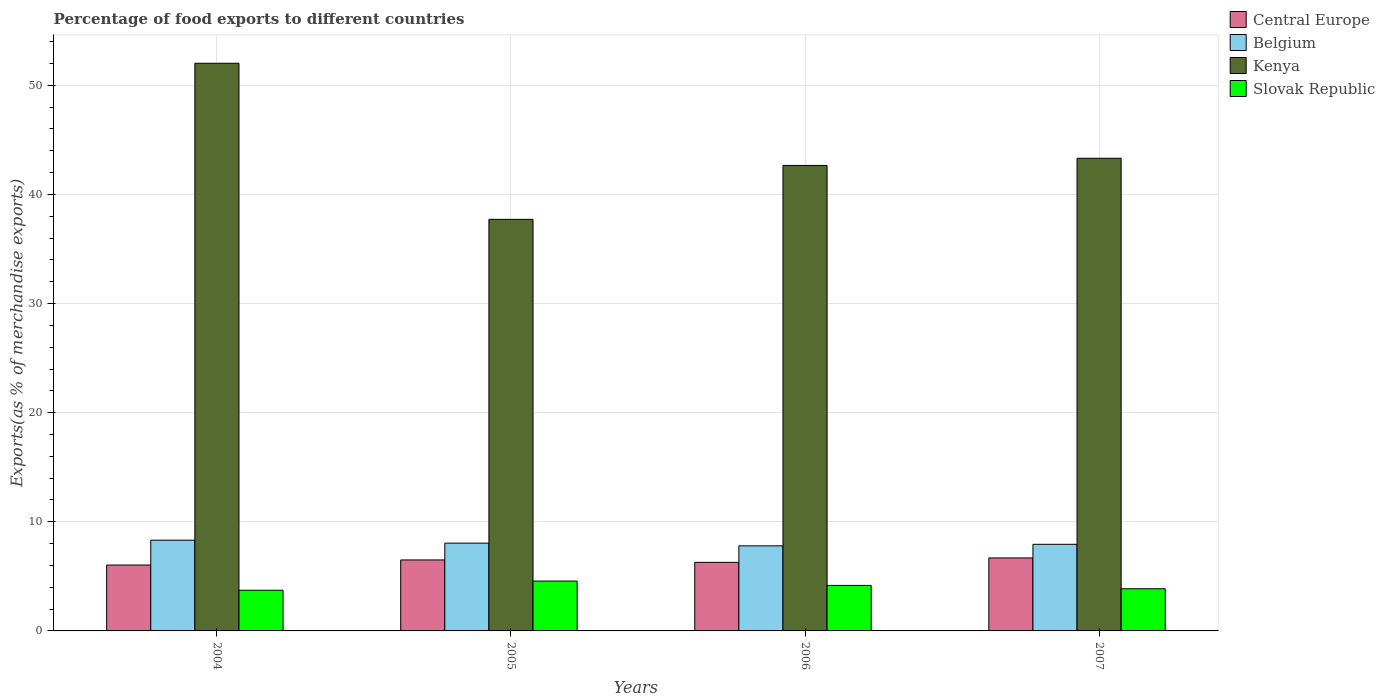Are the number of bars per tick equal to the number of legend labels?
Ensure brevity in your answer.  Yes. Are the number of bars on each tick of the X-axis equal?
Your answer should be compact. Yes. How many bars are there on the 1st tick from the left?
Make the answer very short. 4. How many bars are there on the 4th tick from the right?
Give a very brief answer. 4. In how many cases, is the number of bars for a given year not equal to the number of legend labels?
Your response must be concise. 0. What is the percentage of exports to different countries in Slovak Republic in 2005?
Provide a succinct answer. 4.57. Across all years, what is the maximum percentage of exports to different countries in Central Europe?
Offer a terse response. 6.69. Across all years, what is the minimum percentage of exports to different countries in Central Europe?
Your response must be concise. 6.04. In which year was the percentage of exports to different countries in Belgium maximum?
Ensure brevity in your answer.  2004. What is the total percentage of exports to different countries in Belgium in the graph?
Offer a very short reply. 32.09. What is the difference between the percentage of exports to different countries in Kenya in 2004 and that in 2007?
Provide a short and direct response. 8.7. What is the difference between the percentage of exports to different countries in Slovak Republic in 2005 and the percentage of exports to different countries in Kenya in 2006?
Offer a terse response. -38.09. What is the average percentage of exports to different countries in Belgium per year?
Provide a succinct answer. 8.02. In the year 2007, what is the difference between the percentage of exports to different countries in Belgium and percentage of exports to different countries in Slovak Republic?
Offer a terse response. 4.07. In how many years, is the percentage of exports to different countries in Slovak Republic greater than 30 %?
Make the answer very short. 0. What is the ratio of the percentage of exports to different countries in Slovak Republic in 2004 to that in 2005?
Keep it short and to the point. 0.82. What is the difference between the highest and the second highest percentage of exports to different countries in Central Europe?
Keep it short and to the point. 0.18. What is the difference between the highest and the lowest percentage of exports to different countries in Central Europe?
Provide a short and direct response. 0.65. Is the sum of the percentage of exports to different countries in Central Europe in 2004 and 2007 greater than the maximum percentage of exports to different countries in Belgium across all years?
Your answer should be very brief. Yes. How many bars are there?
Provide a succinct answer. 16. Does the graph contain any zero values?
Give a very brief answer. No. Does the graph contain grids?
Give a very brief answer. Yes. Where does the legend appear in the graph?
Your answer should be very brief. Top right. What is the title of the graph?
Your answer should be compact. Percentage of food exports to different countries. Does "Kyrgyz Republic" appear as one of the legend labels in the graph?
Make the answer very short. No. What is the label or title of the X-axis?
Your response must be concise. Years. What is the label or title of the Y-axis?
Keep it short and to the point. Exports(as % of merchandise exports). What is the Exports(as % of merchandise exports) in Central Europe in 2004?
Offer a very short reply. 6.04. What is the Exports(as % of merchandise exports) of Belgium in 2004?
Your answer should be very brief. 8.31. What is the Exports(as % of merchandise exports) of Kenya in 2004?
Your answer should be compact. 52.02. What is the Exports(as % of merchandise exports) in Slovak Republic in 2004?
Ensure brevity in your answer.  3.73. What is the Exports(as % of merchandise exports) of Central Europe in 2005?
Your response must be concise. 6.5. What is the Exports(as % of merchandise exports) in Belgium in 2005?
Ensure brevity in your answer.  8.05. What is the Exports(as % of merchandise exports) in Kenya in 2005?
Offer a terse response. 37.72. What is the Exports(as % of merchandise exports) of Slovak Republic in 2005?
Provide a succinct answer. 4.57. What is the Exports(as % of merchandise exports) of Central Europe in 2006?
Offer a terse response. 6.29. What is the Exports(as % of merchandise exports) of Belgium in 2006?
Give a very brief answer. 7.8. What is the Exports(as % of merchandise exports) of Kenya in 2006?
Give a very brief answer. 42.66. What is the Exports(as % of merchandise exports) of Slovak Republic in 2006?
Keep it short and to the point. 4.17. What is the Exports(as % of merchandise exports) in Central Europe in 2007?
Give a very brief answer. 6.69. What is the Exports(as % of merchandise exports) of Belgium in 2007?
Provide a short and direct response. 7.94. What is the Exports(as % of merchandise exports) in Kenya in 2007?
Keep it short and to the point. 43.32. What is the Exports(as % of merchandise exports) in Slovak Republic in 2007?
Provide a short and direct response. 3.86. Across all years, what is the maximum Exports(as % of merchandise exports) in Central Europe?
Your answer should be very brief. 6.69. Across all years, what is the maximum Exports(as % of merchandise exports) in Belgium?
Your answer should be very brief. 8.31. Across all years, what is the maximum Exports(as % of merchandise exports) in Kenya?
Your response must be concise. 52.02. Across all years, what is the maximum Exports(as % of merchandise exports) in Slovak Republic?
Ensure brevity in your answer.  4.57. Across all years, what is the minimum Exports(as % of merchandise exports) in Central Europe?
Provide a short and direct response. 6.04. Across all years, what is the minimum Exports(as % of merchandise exports) of Belgium?
Your response must be concise. 7.8. Across all years, what is the minimum Exports(as % of merchandise exports) in Kenya?
Provide a short and direct response. 37.72. Across all years, what is the minimum Exports(as % of merchandise exports) of Slovak Republic?
Keep it short and to the point. 3.73. What is the total Exports(as % of merchandise exports) in Central Europe in the graph?
Keep it short and to the point. 25.52. What is the total Exports(as % of merchandise exports) of Belgium in the graph?
Make the answer very short. 32.09. What is the total Exports(as % of merchandise exports) in Kenya in the graph?
Keep it short and to the point. 175.72. What is the total Exports(as % of merchandise exports) in Slovak Republic in the graph?
Offer a terse response. 16.33. What is the difference between the Exports(as % of merchandise exports) in Central Europe in 2004 and that in 2005?
Your answer should be compact. -0.47. What is the difference between the Exports(as % of merchandise exports) in Belgium in 2004 and that in 2005?
Offer a very short reply. 0.27. What is the difference between the Exports(as % of merchandise exports) in Kenya in 2004 and that in 2005?
Make the answer very short. 14.3. What is the difference between the Exports(as % of merchandise exports) in Slovak Republic in 2004 and that in 2005?
Keep it short and to the point. -0.84. What is the difference between the Exports(as % of merchandise exports) in Central Europe in 2004 and that in 2006?
Your answer should be compact. -0.25. What is the difference between the Exports(as % of merchandise exports) in Belgium in 2004 and that in 2006?
Provide a short and direct response. 0.52. What is the difference between the Exports(as % of merchandise exports) in Kenya in 2004 and that in 2006?
Offer a terse response. 9.36. What is the difference between the Exports(as % of merchandise exports) of Slovak Republic in 2004 and that in 2006?
Provide a short and direct response. -0.44. What is the difference between the Exports(as % of merchandise exports) in Central Europe in 2004 and that in 2007?
Provide a succinct answer. -0.65. What is the difference between the Exports(as % of merchandise exports) of Belgium in 2004 and that in 2007?
Keep it short and to the point. 0.38. What is the difference between the Exports(as % of merchandise exports) of Kenya in 2004 and that in 2007?
Give a very brief answer. 8.7. What is the difference between the Exports(as % of merchandise exports) in Slovak Republic in 2004 and that in 2007?
Offer a terse response. -0.14. What is the difference between the Exports(as % of merchandise exports) in Central Europe in 2005 and that in 2006?
Make the answer very short. 0.22. What is the difference between the Exports(as % of merchandise exports) of Belgium in 2005 and that in 2006?
Make the answer very short. 0.25. What is the difference between the Exports(as % of merchandise exports) of Kenya in 2005 and that in 2006?
Your answer should be very brief. -4.94. What is the difference between the Exports(as % of merchandise exports) in Slovak Republic in 2005 and that in 2006?
Offer a terse response. 0.4. What is the difference between the Exports(as % of merchandise exports) in Central Europe in 2005 and that in 2007?
Offer a terse response. -0.18. What is the difference between the Exports(as % of merchandise exports) in Belgium in 2005 and that in 2007?
Offer a very short reply. 0.11. What is the difference between the Exports(as % of merchandise exports) of Kenya in 2005 and that in 2007?
Your answer should be very brief. -5.6. What is the difference between the Exports(as % of merchandise exports) of Slovak Republic in 2005 and that in 2007?
Your response must be concise. 0.71. What is the difference between the Exports(as % of merchandise exports) in Central Europe in 2006 and that in 2007?
Give a very brief answer. -0.4. What is the difference between the Exports(as % of merchandise exports) in Belgium in 2006 and that in 2007?
Make the answer very short. -0.14. What is the difference between the Exports(as % of merchandise exports) in Kenya in 2006 and that in 2007?
Give a very brief answer. -0.66. What is the difference between the Exports(as % of merchandise exports) in Slovak Republic in 2006 and that in 2007?
Your response must be concise. 0.31. What is the difference between the Exports(as % of merchandise exports) of Central Europe in 2004 and the Exports(as % of merchandise exports) of Belgium in 2005?
Offer a terse response. -2.01. What is the difference between the Exports(as % of merchandise exports) in Central Europe in 2004 and the Exports(as % of merchandise exports) in Kenya in 2005?
Offer a very short reply. -31.68. What is the difference between the Exports(as % of merchandise exports) in Central Europe in 2004 and the Exports(as % of merchandise exports) in Slovak Republic in 2005?
Give a very brief answer. 1.47. What is the difference between the Exports(as % of merchandise exports) of Belgium in 2004 and the Exports(as % of merchandise exports) of Kenya in 2005?
Offer a terse response. -29.41. What is the difference between the Exports(as % of merchandise exports) of Belgium in 2004 and the Exports(as % of merchandise exports) of Slovak Republic in 2005?
Your answer should be compact. 3.74. What is the difference between the Exports(as % of merchandise exports) in Kenya in 2004 and the Exports(as % of merchandise exports) in Slovak Republic in 2005?
Keep it short and to the point. 47.45. What is the difference between the Exports(as % of merchandise exports) of Central Europe in 2004 and the Exports(as % of merchandise exports) of Belgium in 2006?
Keep it short and to the point. -1.76. What is the difference between the Exports(as % of merchandise exports) of Central Europe in 2004 and the Exports(as % of merchandise exports) of Kenya in 2006?
Your answer should be very brief. -36.62. What is the difference between the Exports(as % of merchandise exports) in Central Europe in 2004 and the Exports(as % of merchandise exports) in Slovak Republic in 2006?
Provide a succinct answer. 1.87. What is the difference between the Exports(as % of merchandise exports) of Belgium in 2004 and the Exports(as % of merchandise exports) of Kenya in 2006?
Your answer should be very brief. -34.35. What is the difference between the Exports(as % of merchandise exports) of Belgium in 2004 and the Exports(as % of merchandise exports) of Slovak Republic in 2006?
Your response must be concise. 4.14. What is the difference between the Exports(as % of merchandise exports) in Kenya in 2004 and the Exports(as % of merchandise exports) in Slovak Republic in 2006?
Your response must be concise. 47.85. What is the difference between the Exports(as % of merchandise exports) in Central Europe in 2004 and the Exports(as % of merchandise exports) in Belgium in 2007?
Ensure brevity in your answer.  -1.9. What is the difference between the Exports(as % of merchandise exports) of Central Europe in 2004 and the Exports(as % of merchandise exports) of Kenya in 2007?
Your answer should be compact. -37.28. What is the difference between the Exports(as % of merchandise exports) in Central Europe in 2004 and the Exports(as % of merchandise exports) in Slovak Republic in 2007?
Make the answer very short. 2.17. What is the difference between the Exports(as % of merchandise exports) in Belgium in 2004 and the Exports(as % of merchandise exports) in Kenya in 2007?
Your response must be concise. -35.01. What is the difference between the Exports(as % of merchandise exports) of Belgium in 2004 and the Exports(as % of merchandise exports) of Slovak Republic in 2007?
Keep it short and to the point. 4.45. What is the difference between the Exports(as % of merchandise exports) of Kenya in 2004 and the Exports(as % of merchandise exports) of Slovak Republic in 2007?
Ensure brevity in your answer.  48.16. What is the difference between the Exports(as % of merchandise exports) of Central Europe in 2005 and the Exports(as % of merchandise exports) of Belgium in 2006?
Offer a very short reply. -1.29. What is the difference between the Exports(as % of merchandise exports) in Central Europe in 2005 and the Exports(as % of merchandise exports) in Kenya in 2006?
Keep it short and to the point. -36.16. What is the difference between the Exports(as % of merchandise exports) of Central Europe in 2005 and the Exports(as % of merchandise exports) of Slovak Republic in 2006?
Keep it short and to the point. 2.33. What is the difference between the Exports(as % of merchandise exports) of Belgium in 2005 and the Exports(as % of merchandise exports) of Kenya in 2006?
Offer a very short reply. -34.61. What is the difference between the Exports(as % of merchandise exports) in Belgium in 2005 and the Exports(as % of merchandise exports) in Slovak Republic in 2006?
Provide a short and direct response. 3.88. What is the difference between the Exports(as % of merchandise exports) in Kenya in 2005 and the Exports(as % of merchandise exports) in Slovak Republic in 2006?
Your answer should be very brief. 33.55. What is the difference between the Exports(as % of merchandise exports) in Central Europe in 2005 and the Exports(as % of merchandise exports) in Belgium in 2007?
Provide a short and direct response. -1.43. What is the difference between the Exports(as % of merchandise exports) of Central Europe in 2005 and the Exports(as % of merchandise exports) of Kenya in 2007?
Offer a very short reply. -36.81. What is the difference between the Exports(as % of merchandise exports) of Central Europe in 2005 and the Exports(as % of merchandise exports) of Slovak Republic in 2007?
Provide a short and direct response. 2.64. What is the difference between the Exports(as % of merchandise exports) of Belgium in 2005 and the Exports(as % of merchandise exports) of Kenya in 2007?
Offer a very short reply. -35.27. What is the difference between the Exports(as % of merchandise exports) in Belgium in 2005 and the Exports(as % of merchandise exports) in Slovak Republic in 2007?
Ensure brevity in your answer.  4.18. What is the difference between the Exports(as % of merchandise exports) in Kenya in 2005 and the Exports(as % of merchandise exports) in Slovak Republic in 2007?
Your answer should be compact. 33.85. What is the difference between the Exports(as % of merchandise exports) of Central Europe in 2006 and the Exports(as % of merchandise exports) of Belgium in 2007?
Your answer should be very brief. -1.65. What is the difference between the Exports(as % of merchandise exports) of Central Europe in 2006 and the Exports(as % of merchandise exports) of Kenya in 2007?
Your answer should be very brief. -37.03. What is the difference between the Exports(as % of merchandise exports) of Central Europe in 2006 and the Exports(as % of merchandise exports) of Slovak Republic in 2007?
Your response must be concise. 2.42. What is the difference between the Exports(as % of merchandise exports) of Belgium in 2006 and the Exports(as % of merchandise exports) of Kenya in 2007?
Offer a terse response. -35.52. What is the difference between the Exports(as % of merchandise exports) in Belgium in 2006 and the Exports(as % of merchandise exports) in Slovak Republic in 2007?
Your response must be concise. 3.93. What is the difference between the Exports(as % of merchandise exports) in Kenya in 2006 and the Exports(as % of merchandise exports) in Slovak Republic in 2007?
Offer a terse response. 38.8. What is the average Exports(as % of merchandise exports) in Central Europe per year?
Offer a terse response. 6.38. What is the average Exports(as % of merchandise exports) in Belgium per year?
Provide a succinct answer. 8.02. What is the average Exports(as % of merchandise exports) in Kenya per year?
Your answer should be compact. 43.93. What is the average Exports(as % of merchandise exports) of Slovak Republic per year?
Ensure brevity in your answer.  4.08. In the year 2004, what is the difference between the Exports(as % of merchandise exports) of Central Europe and Exports(as % of merchandise exports) of Belgium?
Provide a succinct answer. -2.28. In the year 2004, what is the difference between the Exports(as % of merchandise exports) of Central Europe and Exports(as % of merchandise exports) of Kenya?
Your answer should be very brief. -45.99. In the year 2004, what is the difference between the Exports(as % of merchandise exports) of Central Europe and Exports(as % of merchandise exports) of Slovak Republic?
Provide a short and direct response. 2.31. In the year 2004, what is the difference between the Exports(as % of merchandise exports) of Belgium and Exports(as % of merchandise exports) of Kenya?
Ensure brevity in your answer.  -43.71. In the year 2004, what is the difference between the Exports(as % of merchandise exports) of Belgium and Exports(as % of merchandise exports) of Slovak Republic?
Make the answer very short. 4.59. In the year 2004, what is the difference between the Exports(as % of merchandise exports) in Kenya and Exports(as % of merchandise exports) in Slovak Republic?
Your response must be concise. 48.3. In the year 2005, what is the difference between the Exports(as % of merchandise exports) in Central Europe and Exports(as % of merchandise exports) in Belgium?
Your response must be concise. -1.54. In the year 2005, what is the difference between the Exports(as % of merchandise exports) in Central Europe and Exports(as % of merchandise exports) in Kenya?
Keep it short and to the point. -31.21. In the year 2005, what is the difference between the Exports(as % of merchandise exports) of Central Europe and Exports(as % of merchandise exports) of Slovak Republic?
Offer a very short reply. 1.93. In the year 2005, what is the difference between the Exports(as % of merchandise exports) of Belgium and Exports(as % of merchandise exports) of Kenya?
Your answer should be very brief. -29.67. In the year 2005, what is the difference between the Exports(as % of merchandise exports) of Belgium and Exports(as % of merchandise exports) of Slovak Republic?
Your answer should be very brief. 3.48. In the year 2005, what is the difference between the Exports(as % of merchandise exports) in Kenya and Exports(as % of merchandise exports) in Slovak Republic?
Your response must be concise. 33.15. In the year 2006, what is the difference between the Exports(as % of merchandise exports) in Central Europe and Exports(as % of merchandise exports) in Belgium?
Your answer should be very brief. -1.51. In the year 2006, what is the difference between the Exports(as % of merchandise exports) of Central Europe and Exports(as % of merchandise exports) of Kenya?
Your answer should be very brief. -36.37. In the year 2006, what is the difference between the Exports(as % of merchandise exports) in Central Europe and Exports(as % of merchandise exports) in Slovak Republic?
Your answer should be very brief. 2.12. In the year 2006, what is the difference between the Exports(as % of merchandise exports) in Belgium and Exports(as % of merchandise exports) in Kenya?
Provide a short and direct response. -34.86. In the year 2006, what is the difference between the Exports(as % of merchandise exports) in Belgium and Exports(as % of merchandise exports) in Slovak Republic?
Ensure brevity in your answer.  3.63. In the year 2006, what is the difference between the Exports(as % of merchandise exports) in Kenya and Exports(as % of merchandise exports) in Slovak Republic?
Offer a very short reply. 38.49. In the year 2007, what is the difference between the Exports(as % of merchandise exports) of Central Europe and Exports(as % of merchandise exports) of Belgium?
Give a very brief answer. -1.25. In the year 2007, what is the difference between the Exports(as % of merchandise exports) of Central Europe and Exports(as % of merchandise exports) of Kenya?
Provide a succinct answer. -36.63. In the year 2007, what is the difference between the Exports(as % of merchandise exports) in Central Europe and Exports(as % of merchandise exports) in Slovak Republic?
Offer a very short reply. 2.82. In the year 2007, what is the difference between the Exports(as % of merchandise exports) of Belgium and Exports(as % of merchandise exports) of Kenya?
Your answer should be compact. -35.38. In the year 2007, what is the difference between the Exports(as % of merchandise exports) in Belgium and Exports(as % of merchandise exports) in Slovak Republic?
Make the answer very short. 4.07. In the year 2007, what is the difference between the Exports(as % of merchandise exports) in Kenya and Exports(as % of merchandise exports) in Slovak Republic?
Provide a succinct answer. 39.45. What is the ratio of the Exports(as % of merchandise exports) of Central Europe in 2004 to that in 2005?
Ensure brevity in your answer.  0.93. What is the ratio of the Exports(as % of merchandise exports) in Kenya in 2004 to that in 2005?
Give a very brief answer. 1.38. What is the ratio of the Exports(as % of merchandise exports) of Slovak Republic in 2004 to that in 2005?
Provide a short and direct response. 0.82. What is the ratio of the Exports(as % of merchandise exports) of Central Europe in 2004 to that in 2006?
Keep it short and to the point. 0.96. What is the ratio of the Exports(as % of merchandise exports) in Belgium in 2004 to that in 2006?
Keep it short and to the point. 1.07. What is the ratio of the Exports(as % of merchandise exports) of Kenya in 2004 to that in 2006?
Offer a terse response. 1.22. What is the ratio of the Exports(as % of merchandise exports) of Slovak Republic in 2004 to that in 2006?
Make the answer very short. 0.89. What is the ratio of the Exports(as % of merchandise exports) in Central Europe in 2004 to that in 2007?
Keep it short and to the point. 0.9. What is the ratio of the Exports(as % of merchandise exports) of Belgium in 2004 to that in 2007?
Offer a very short reply. 1.05. What is the ratio of the Exports(as % of merchandise exports) of Kenya in 2004 to that in 2007?
Provide a short and direct response. 1.2. What is the ratio of the Exports(as % of merchandise exports) in Slovak Republic in 2004 to that in 2007?
Make the answer very short. 0.96. What is the ratio of the Exports(as % of merchandise exports) of Central Europe in 2005 to that in 2006?
Give a very brief answer. 1.03. What is the ratio of the Exports(as % of merchandise exports) in Belgium in 2005 to that in 2006?
Offer a very short reply. 1.03. What is the ratio of the Exports(as % of merchandise exports) in Kenya in 2005 to that in 2006?
Provide a short and direct response. 0.88. What is the ratio of the Exports(as % of merchandise exports) in Slovak Republic in 2005 to that in 2006?
Make the answer very short. 1.1. What is the ratio of the Exports(as % of merchandise exports) of Central Europe in 2005 to that in 2007?
Offer a very short reply. 0.97. What is the ratio of the Exports(as % of merchandise exports) of Belgium in 2005 to that in 2007?
Offer a very short reply. 1.01. What is the ratio of the Exports(as % of merchandise exports) of Kenya in 2005 to that in 2007?
Your answer should be very brief. 0.87. What is the ratio of the Exports(as % of merchandise exports) in Slovak Republic in 2005 to that in 2007?
Your answer should be very brief. 1.18. What is the ratio of the Exports(as % of merchandise exports) of Central Europe in 2006 to that in 2007?
Your answer should be very brief. 0.94. What is the ratio of the Exports(as % of merchandise exports) of Belgium in 2006 to that in 2007?
Your answer should be very brief. 0.98. What is the ratio of the Exports(as % of merchandise exports) of Kenya in 2006 to that in 2007?
Provide a succinct answer. 0.98. What is the ratio of the Exports(as % of merchandise exports) of Slovak Republic in 2006 to that in 2007?
Your answer should be very brief. 1.08. What is the difference between the highest and the second highest Exports(as % of merchandise exports) in Central Europe?
Give a very brief answer. 0.18. What is the difference between the highest and the second highest Exports(as % of merchandise exports) of Belgium?
Give a very brief answer. 0.27. What is the difference between the highest and the second highest Exports(as % of merchandise exports) of Kenya?
Your answer should be compact. 8.7. What is the difference between the highest and the second highest Exports(as % of merchandise exports) in Slovak Republic?
Keep it short and to the point. 0.4. What is the difference between the highest and the lowest Exports(as % of merchandise exports) in Central Europe?
Provide a succinct answer. 0.65. What is the difference between the highest and the lowest Exports(as % of merchandise exports) of Belgium?
Provide a short and direct response. 0.52. What is the difference between the highest and the lowest Exports(as % of merchandise exports) of Kenya?
Offer a terse response. 14.3. What is the difference between the highest and the lowest Exports(as % of merchandise exports) in Slovak Republic?
Your response must be concise. 0.84. 